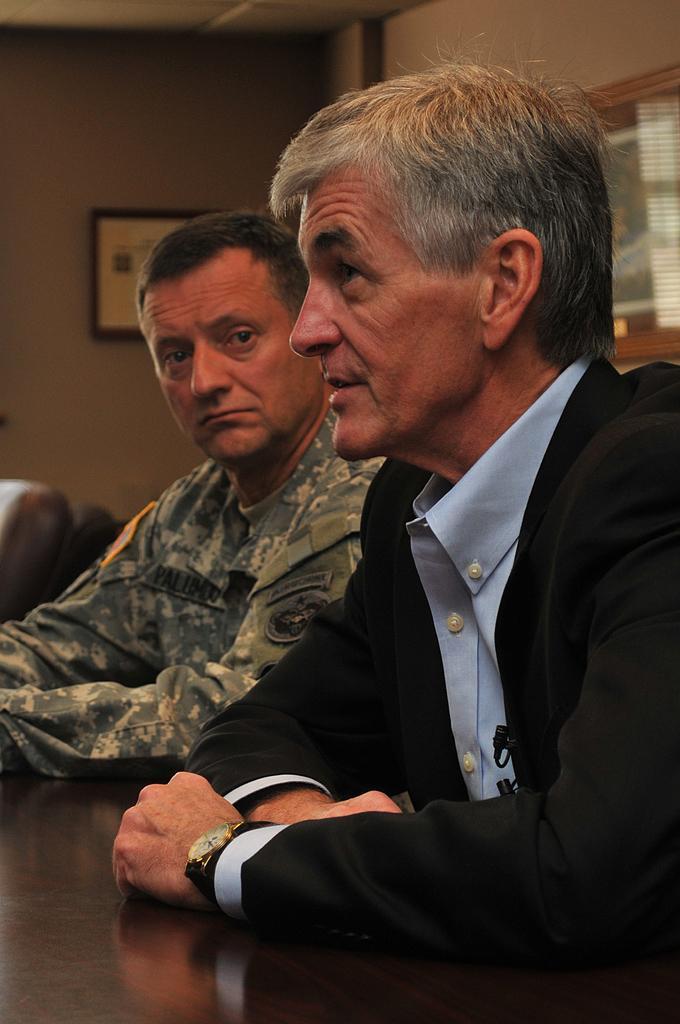Could you give a brief overview of what you see in this image? In this image two people are sitting. A right most person is speaking and leftmost person is listening. 